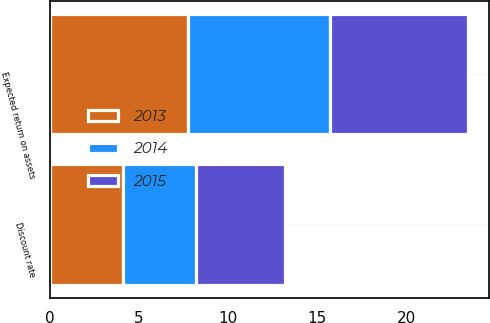Convert chart. <chart><loc_0><loc_0><loc_500><loc_500><stacked_bar_chart><ecel><fcel>Discount rate<fcel>Expected return on assets<nl><fcel>2013<fcel>4.1<fcel>7.75<nl><fcel>2015<fcel>4.98<fcel>7.75<nl><fcel>2014<fcel>4.14<fcel>8<nl></chart> 